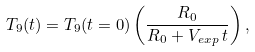Convert formula to latex. <formula><loc_0><loc_0><loc_500><loc_500>T _ { 9 } ( t ) = T _ { 9 } ( t = 0 ) \left ( \frac { R _ { 0 } } { { R _ { 0 } } + V _ { e x p } \, t } \right ) ,</formula> 